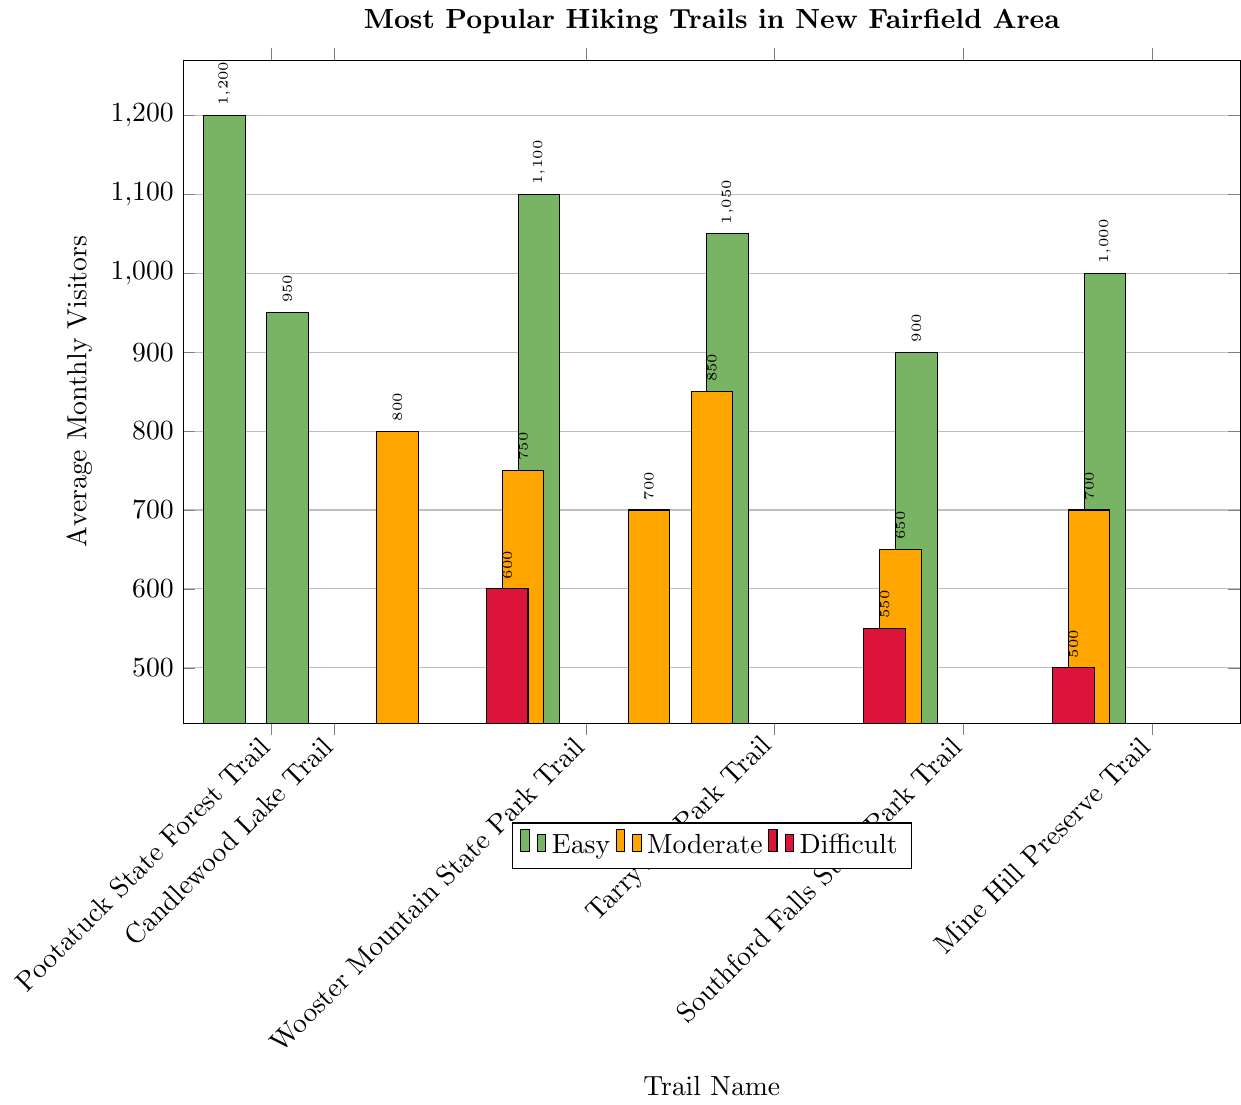Which trail has the highest average monthly visitors? To determine the trail with the highest average monthly visitors, we need to find the trail with the tallest bar in the bar chart. The tallest bar corresponds to the Pootatuck State Forest Trail with 1200 visitors.
Answer: Pootatuck State Forest Trail Which difficulty level has the highest average monthly visitors across all trails? To determine the difficulty level with the highest average monthly visitors, sum the visitors for each difficulty category. Calculate the totals for Easy, Moderate, and Difficult categories. Easy: 1200 + 950 + 1100 + 1050 + 900 + 1000 = 6200, Moderate: 800 + 750 + 700 + 850 + 650 + 700 = 4450, Difficult: 600 + 550 + 500 = 1650. Compare the sums, the Easy category has the highest total.
Answer: Easy How many more average monthly visitors does the Mine Hill Preserve Trail have compared to the Naugatuck State Forest Trail? Subtract the average monthly visitors of the Naugatuck State Forest Trail from the Mine Hill Preserve Trail. Mine Hill Preserve Trail has 1000 visitors and Naugatuck State Forest Trail has 500 visitors. 1000 - 500 = 500
Answer: 500 Which trail in the Difficult category has the fewest average monthly visitors? To find the trail with the fewest visitors in the Difficult category, compare the heights of the bars corresponding to the trails in this category. The Naugatuck State Forest Trail has the fewest visitors with 500.
Answer: Naugatuck State Forest Trail What is the combined average monthly visitors for Squantz Pond State Park Loop and Lake Lillinonah Trail? Add the average monthly visitors for Squantz Pond State Park Loop and Lake Lillinonah Trail. Squantz Pond State Park Loop has 800 visitors and Lake Lillinonah Trail has 700 visitors. 800 + 700 = 1500
Answer: 1500 Which trail in the Easy category has the second highest number of average monthly visitors? To find the second highest number of visitors in the Easy category, sort the trails by the number of visitors in descending order and identify the second one. The Wooster Mountain State Park Trail has the second highest number of visitors with 1100.
Answer: Wooster Mountain State Park Trail How do the average monthly visitors of Bear Mountain Trail compare to Lovers Leap State Park Trail? Compare the number of average monthly visitors of Bear Mountain Trail and Lovers Leap State Park Trail. Bear Mountain Trail has 600 visitors, while Lovers Leap State Park Trail has 750 visitors. Bear Mountain Trail has fewer visitors.
Answer: Bear Mountain Trail has fewer visitors What's the average number of monthly visitors for the Moderate difficulty level? Calculate the average by summing the visitors of all Moderate difficulty trails and dividing by the number of those trails. Total visitors for Moderate is 4450, and there are 6 trails. 4450/6 = ~741.67
Answer: ~741.67 How many trails have more than 1000 average monthly visitors? Count the bars with heights above 1000 visitors. There are 3 bars: Pootatuck State Forest Trail (1200), Wooster Mountain State Park Trail (1100), and Tarrywile Park Trail (1050).
Answer: 3 Which Moderate trail has more average monthly visitors, Collis P. Huntington State Park Trail or Lovers Leap State Park Trail? Compare the number of visitors for Collis P. Huntington State Park Trail and Lovers Leap State Park Trail. Collis P. Huntington has 850 visitors, while Lovers Leap has 750. Collis P. Huntington has more visitors.
Answer: Collis P. Huntington State Park Trail 